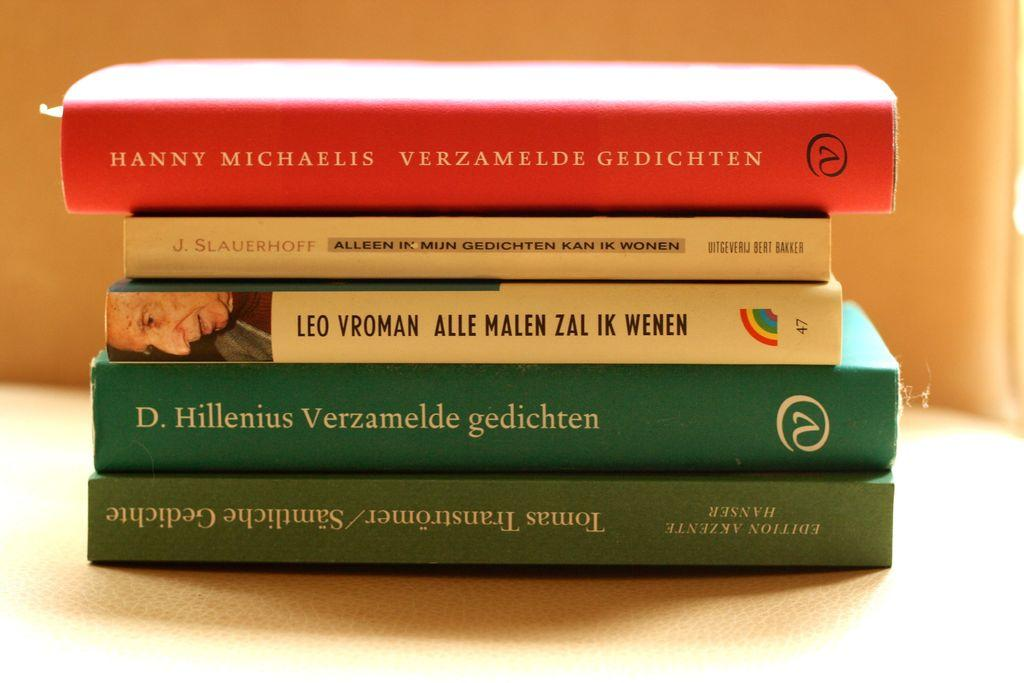<image>
Render a clear and concise summary of the photo. A book by Leo Vroman is in between a stack of four other books. 